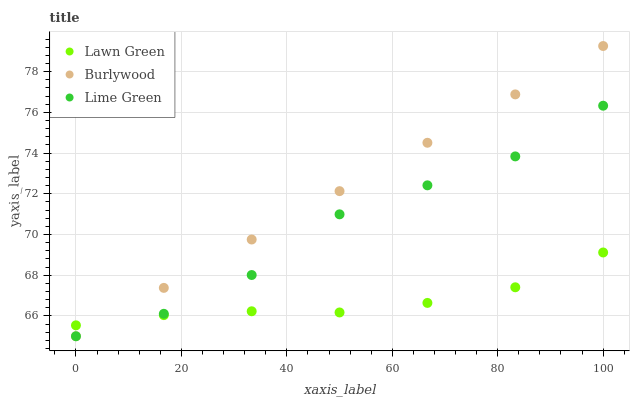Does Lawn Green have the minimum area under the curve?
Answer yes or no. Yes. Does Burlywood have the maximum area under the curve?
Answer yes or no. Yes. Does Lime Green have the minimum area under the curve?
Answer yes or no. No. Does Lime Green have the maximum area under the curve?
Answer yes or no. No. Is Burlywood the smoothest?
Answer yes or no. Yes. Is Lime Green the roughest?
Answer yes or no. Yes. Is Lawn Green the smoothest?
Answer yes or no. No. Is Lawn Green the roughest?
Answer yes or no. No. Does Burlywood have the lowest value?
Answer yes or no. Yes. Does Lawn Green have the lowest value?
Answer yes or no. No. Does Burlywood have the highest value?
Answer yes or no. Yes. Does Lime Green have the highest value?
Answer yes or no. No. Does Lawn Green intersect Lime Green?
Answer yes or no. Yes. Is Lawn Green less than Lime Green?
Answer yes or no. No. Is Lawn Green greater than Lime Green?
Answer yes or no. No. 